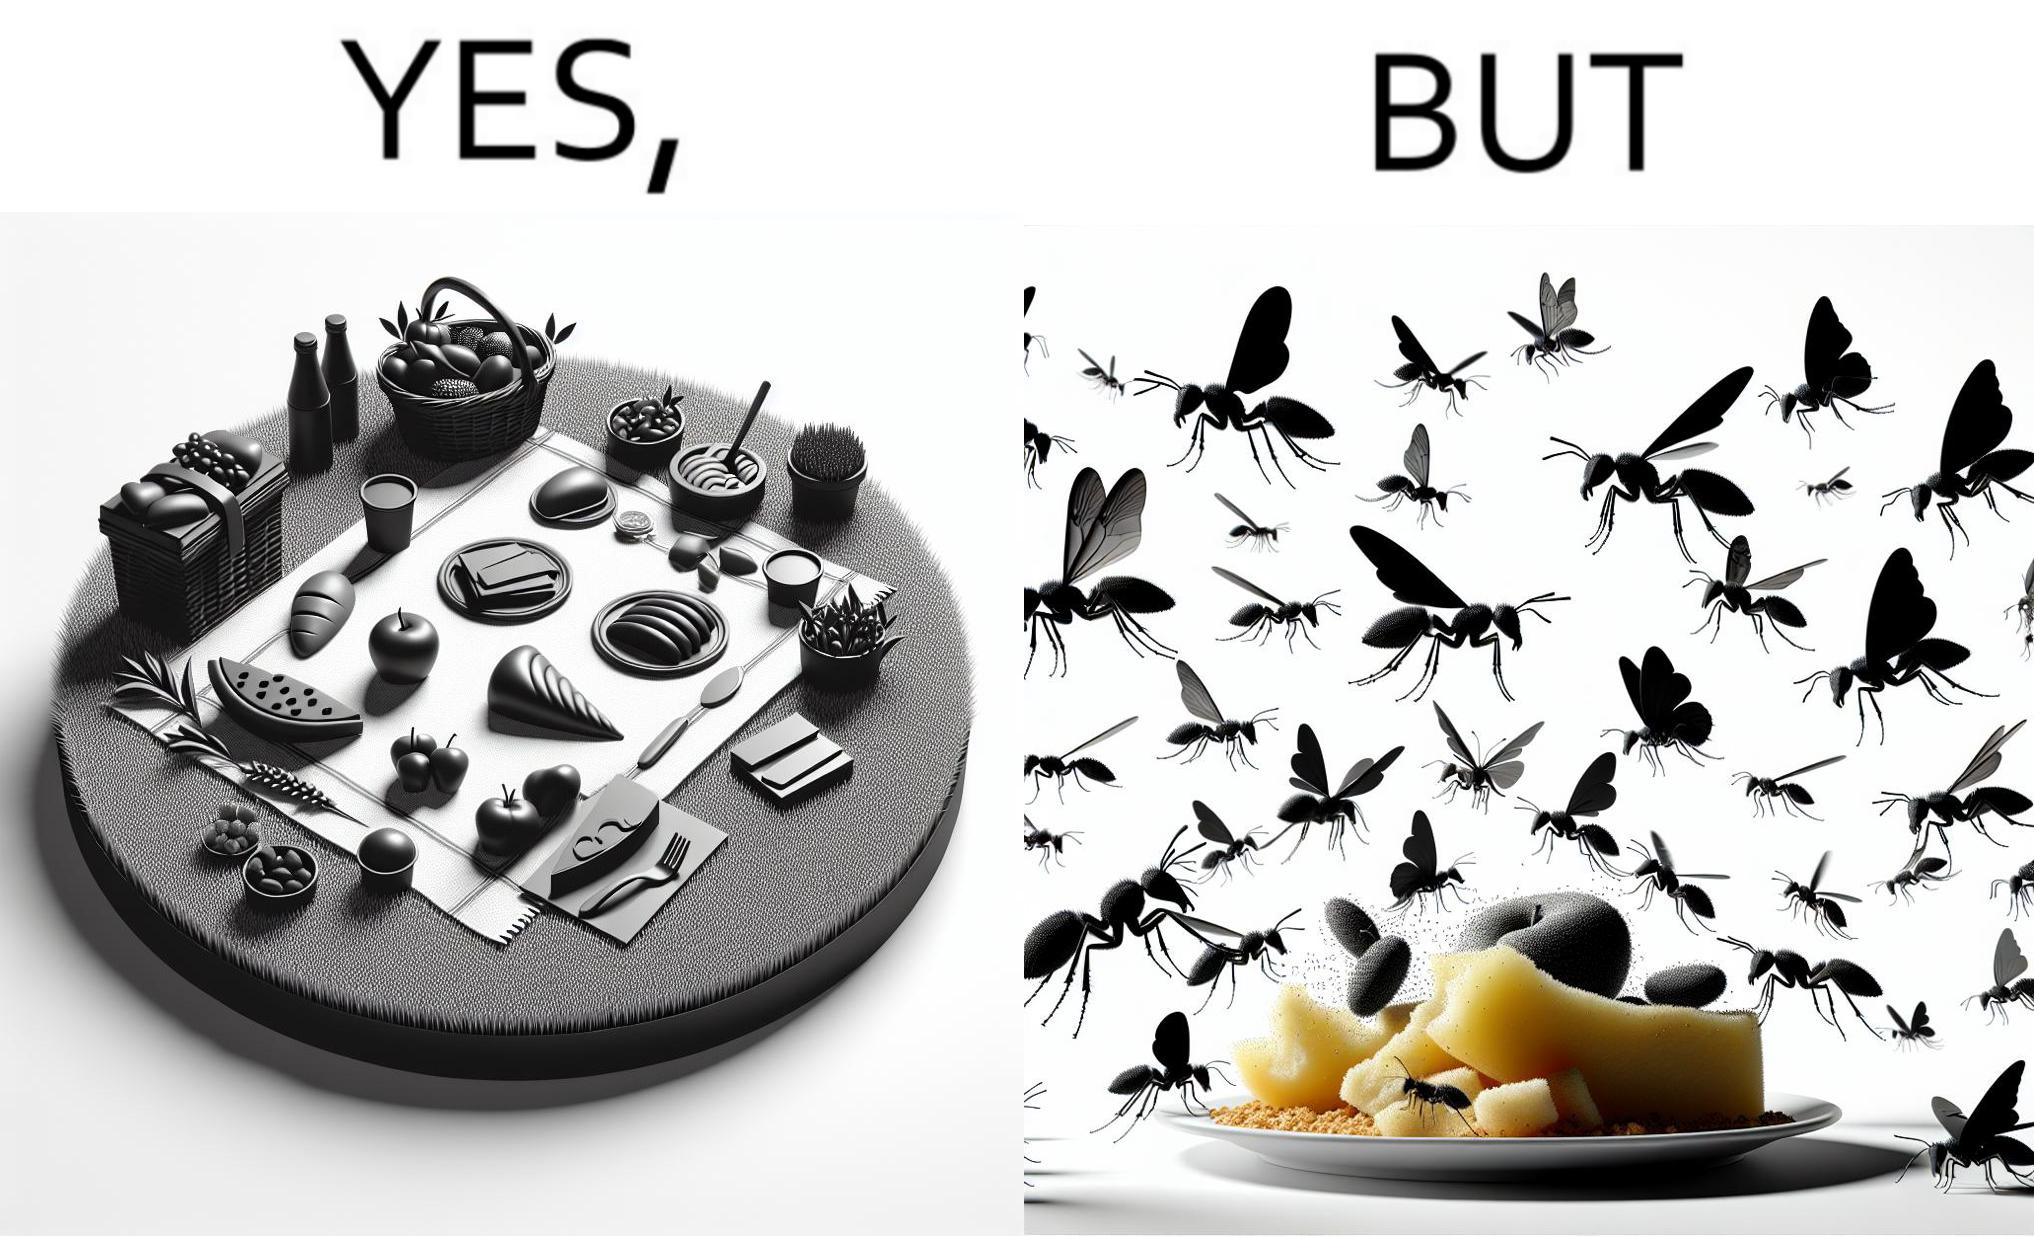Describe the contrast between the left and right parts of this image. In the left part of the image: The food is kept on a blanket in a garden. In the right part of the image: Some bugs are attracting towards the food. 